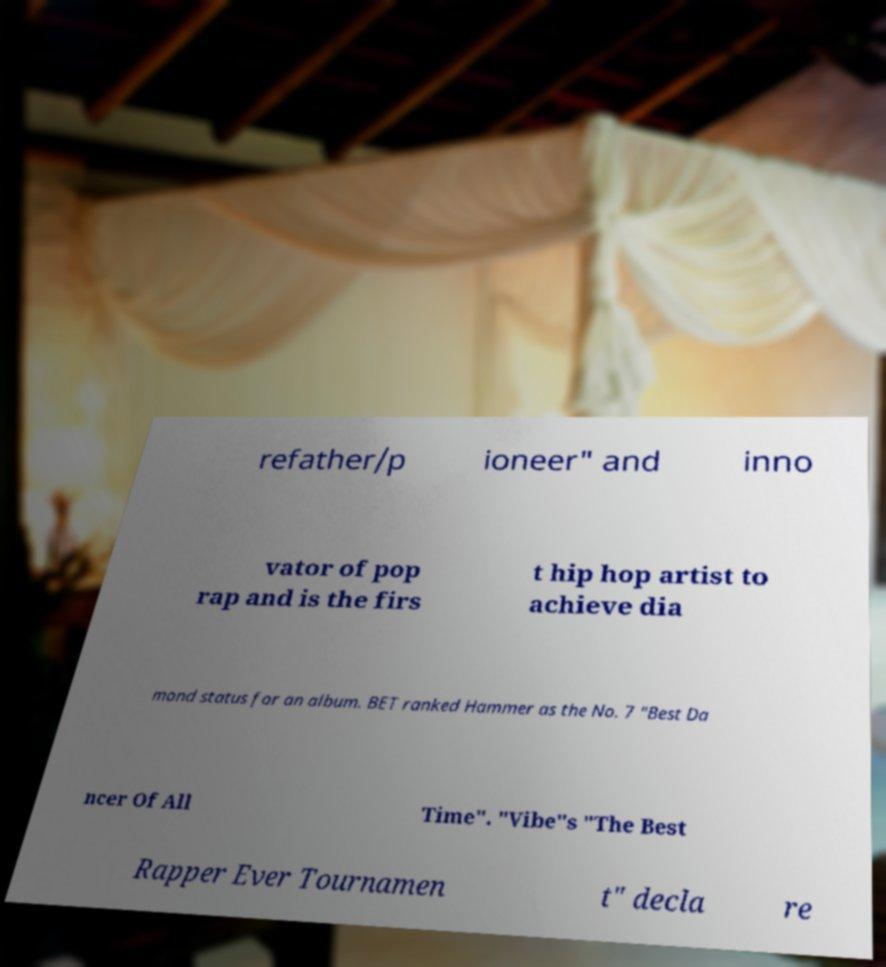Can you read and provide the text displayed in the image?This photo seems to have some interesting text. Can you extract and type it out for me? refather/p ioneer" and inno vator of pop rap and is the firs t hip hop artist to achieve dia mond status for an album. BET ranked Hammer as the No. 7 "Best Da ncer Of All Time". "Vibe"s "The Best Rapper Ever Tournamen t" decla re 